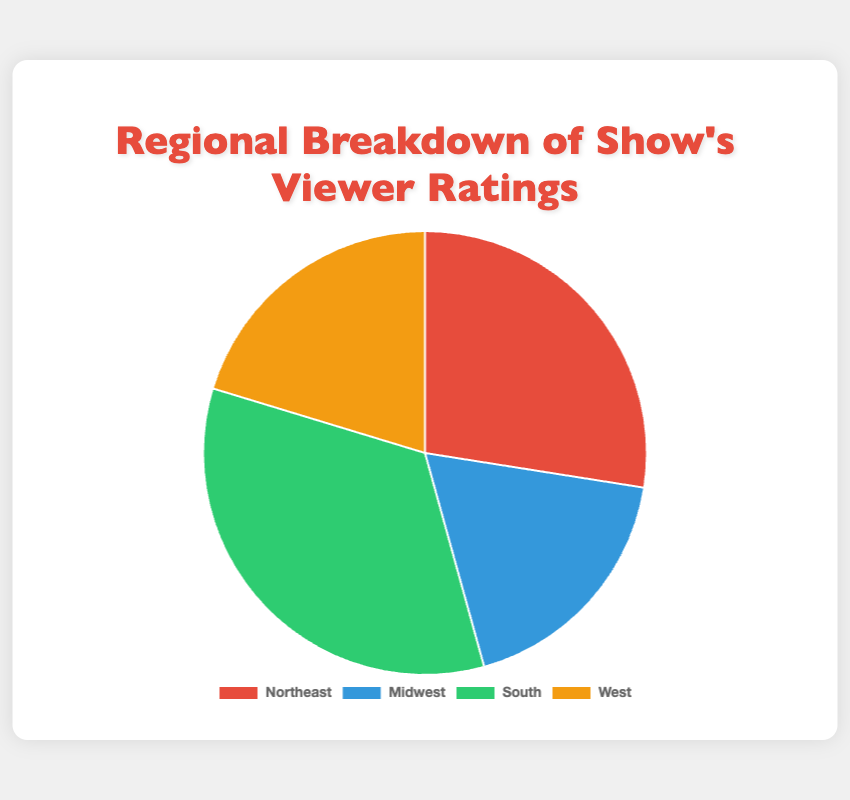What region has the highest viewer rating percentage? The pie chart shows that the South has the largest segment. The South's percentage of 34.0% is the highest among the regions.
Answer: South What is the combined viewer rating percentage for the Northeast and the Midwest? Add the percentages of the Northeast and Midwest. Northeast has 27.5% and Midwest has 18.2%, so combined they are 27.5% + 18.2% = 45.7%.
Answer: 45.7% Which region has a smaller viewer rating percentage than the West? The pie chart indicates that the Midwest has a smaller percentage than the West, with the Midwest at 18.2% compared to the West at 20.3%.
Answer: Midwest What is the average viewer rating percentage for the Midwest and the West? Add the percentages for the Midwest and the West and then divide by 2. Midwest has 18.2% and West has 20.3%, so (18.2% + 20.3%) / 2 = 19.25%.
Answer: 19.25% How much more is the viewer rating percentage for the South compared to the Midwest? Subtract the Midwest percentage from the South percentage. South has 34.0% and Midwest has 18.2%, so 34.0% - 18.2% = 15.8%.
Answer: 15.8% Which color represents the Northeast region in the chart? The pie chart uses different colors for each region. The Northeast is represented by the red segment.
Answer: Red What is the sum of viewer rating percentages for the West and the South? Add the percentages for the West and the South. West has 20.3% and South has 34.0%, so 20.3% + 34.0% = 54.3%.
Answer: 54.3% What is the difference in viewer rating percentage between the Northeast and the West? Subtract the West percentage from the Northeast percentage. Northeast has 27.5% and West has 20.3%, so 27.5% - 20.3% = 7.2%.
Answer: 7.2% What region is represented by the green segment of the pie chart? The pie chart's green segment corresponds to the South region.
Answer: South 